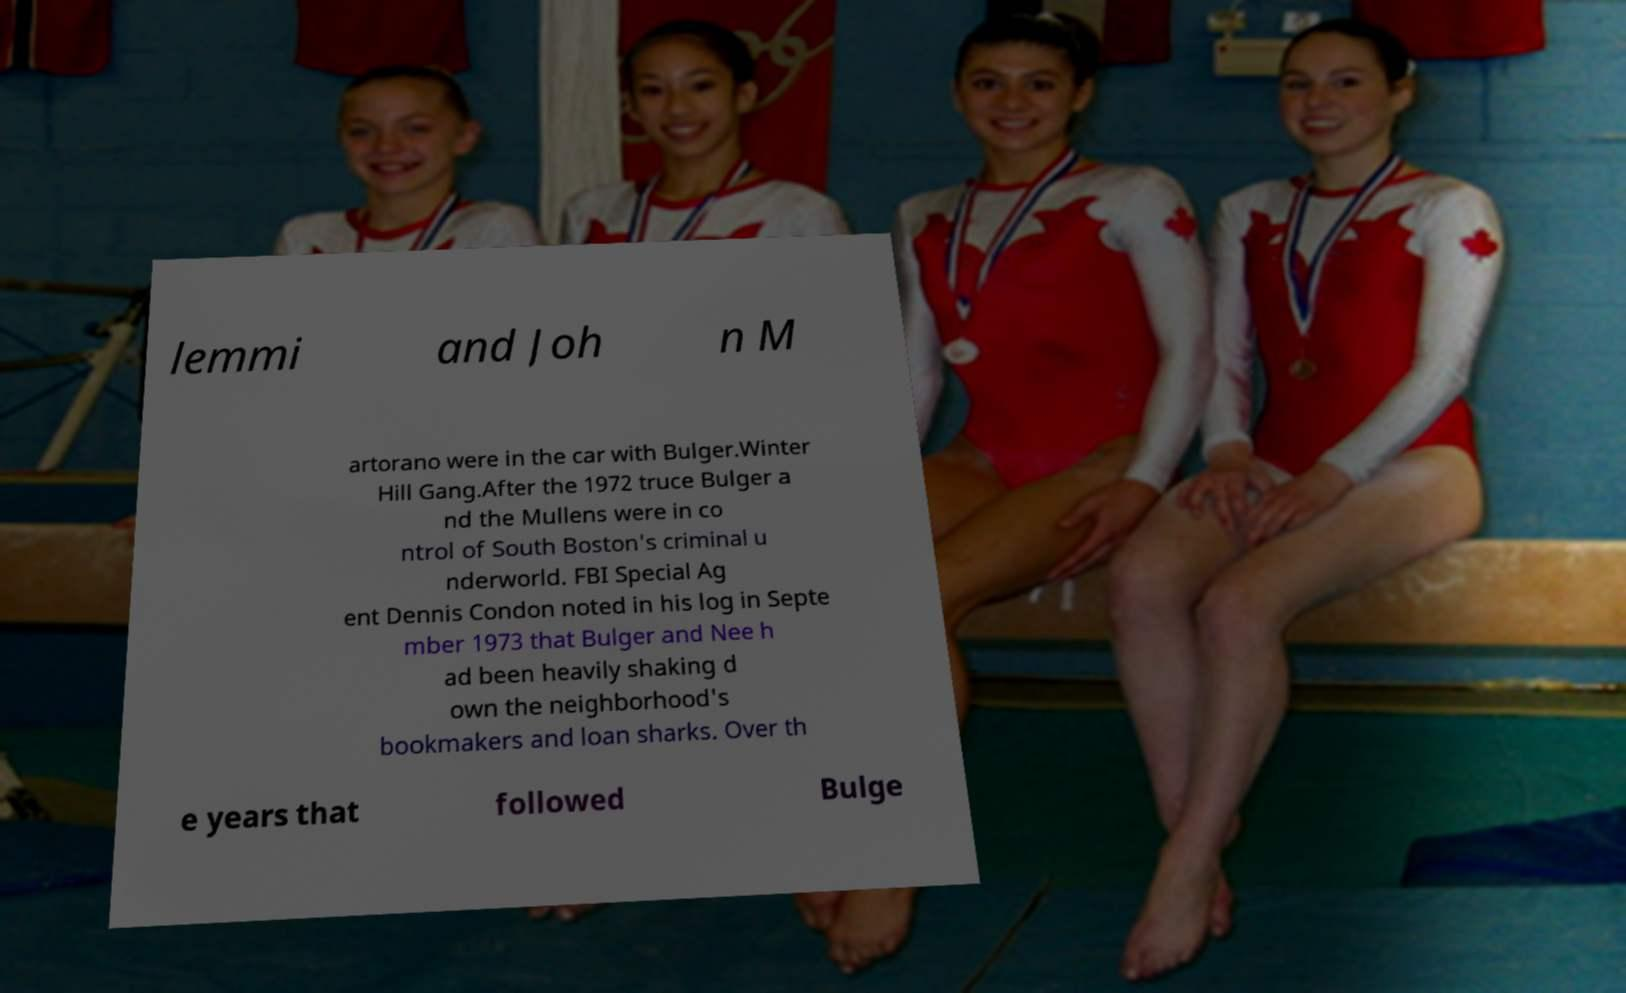What messages or text are displayed in this image? I need them in a readable, typed format. lemmi and Joh n M artorano were in the car with Bulger.Winter Hill Gang.After the 1972 truce Bulger a nd the Mullens were in co ntrol of South Boston's criminal u nderworld. FBI Special Ag ent Dennis Condon noted in his log in Septe mber 1973 that Bulger and Nee h ad been heavily shaking d own the neighborhood's bookmakers and loan sharks. Over th e years that followed Bulge 